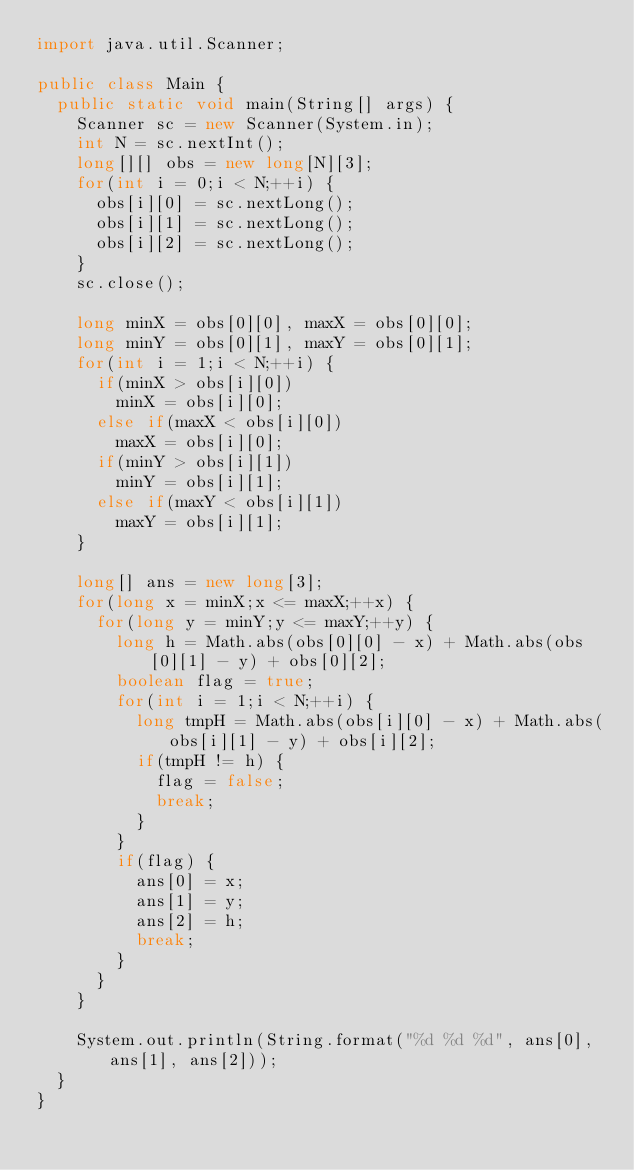<code> <loc_0><loc_0><loc_500><loc_500><_Java_>import java.util.Scanner;

public class Main {
	public static void main(String[] args) {
		Scanner sc = new Scanner(System.in);
		int N = sc.nextInt();
		long[][] obs = new long[N][3];
		for(int i = 0;i < N;++i) {
			obs[i][0] = sc.nextLong();
			obs[i][1] = sc.nextLong();
			obs[i][2] = sc.nextLong();
		}
		sc.close();
		
		long minX = obs[0][0], maxX = obs[0][0];
		long minY = obs[0][1], maxY = obs[0][1];
		for(int i = 1;i < N;++i) {
			if(minX > obs[i][0])
				minX = obs[i][0];
			else if(maxX < obs[i][0])
				maxX = obs[i][0];
			if(minY > obs[i][1])
				minY = obs[i][1];
			else if(maxY < obs[i][1])
				maxY = obs[i][1];
		}
		
		long[] ans = new long[3];
		for(long x = minX;x <= maxX;++x) {
			for(long y = minY;y <= maxY;++y) {
				long h = Math.abs(obs[0][0] - x) + Math.abs(obs[0][1] - y) + obs[0][2];
				boolean flag = true;
				for(int i = 1;i < N;++i) {
					long tmpH = Math.abs(obs[i][0] - x) + Math.abs(obs[i][1] - y) + obs[i][2];
					if(tmpH != h) {
						flag = false;
						break;
					}
				}
				if(flag) {
					ans[0] = x;
					ans[1] = y;
					ans[2] = h;
					break;
				}
			}
		}
		
		System.out.println(String.format("%d %d %d", ans[0], ans[1], ans[2]));
	}
}
</code> 